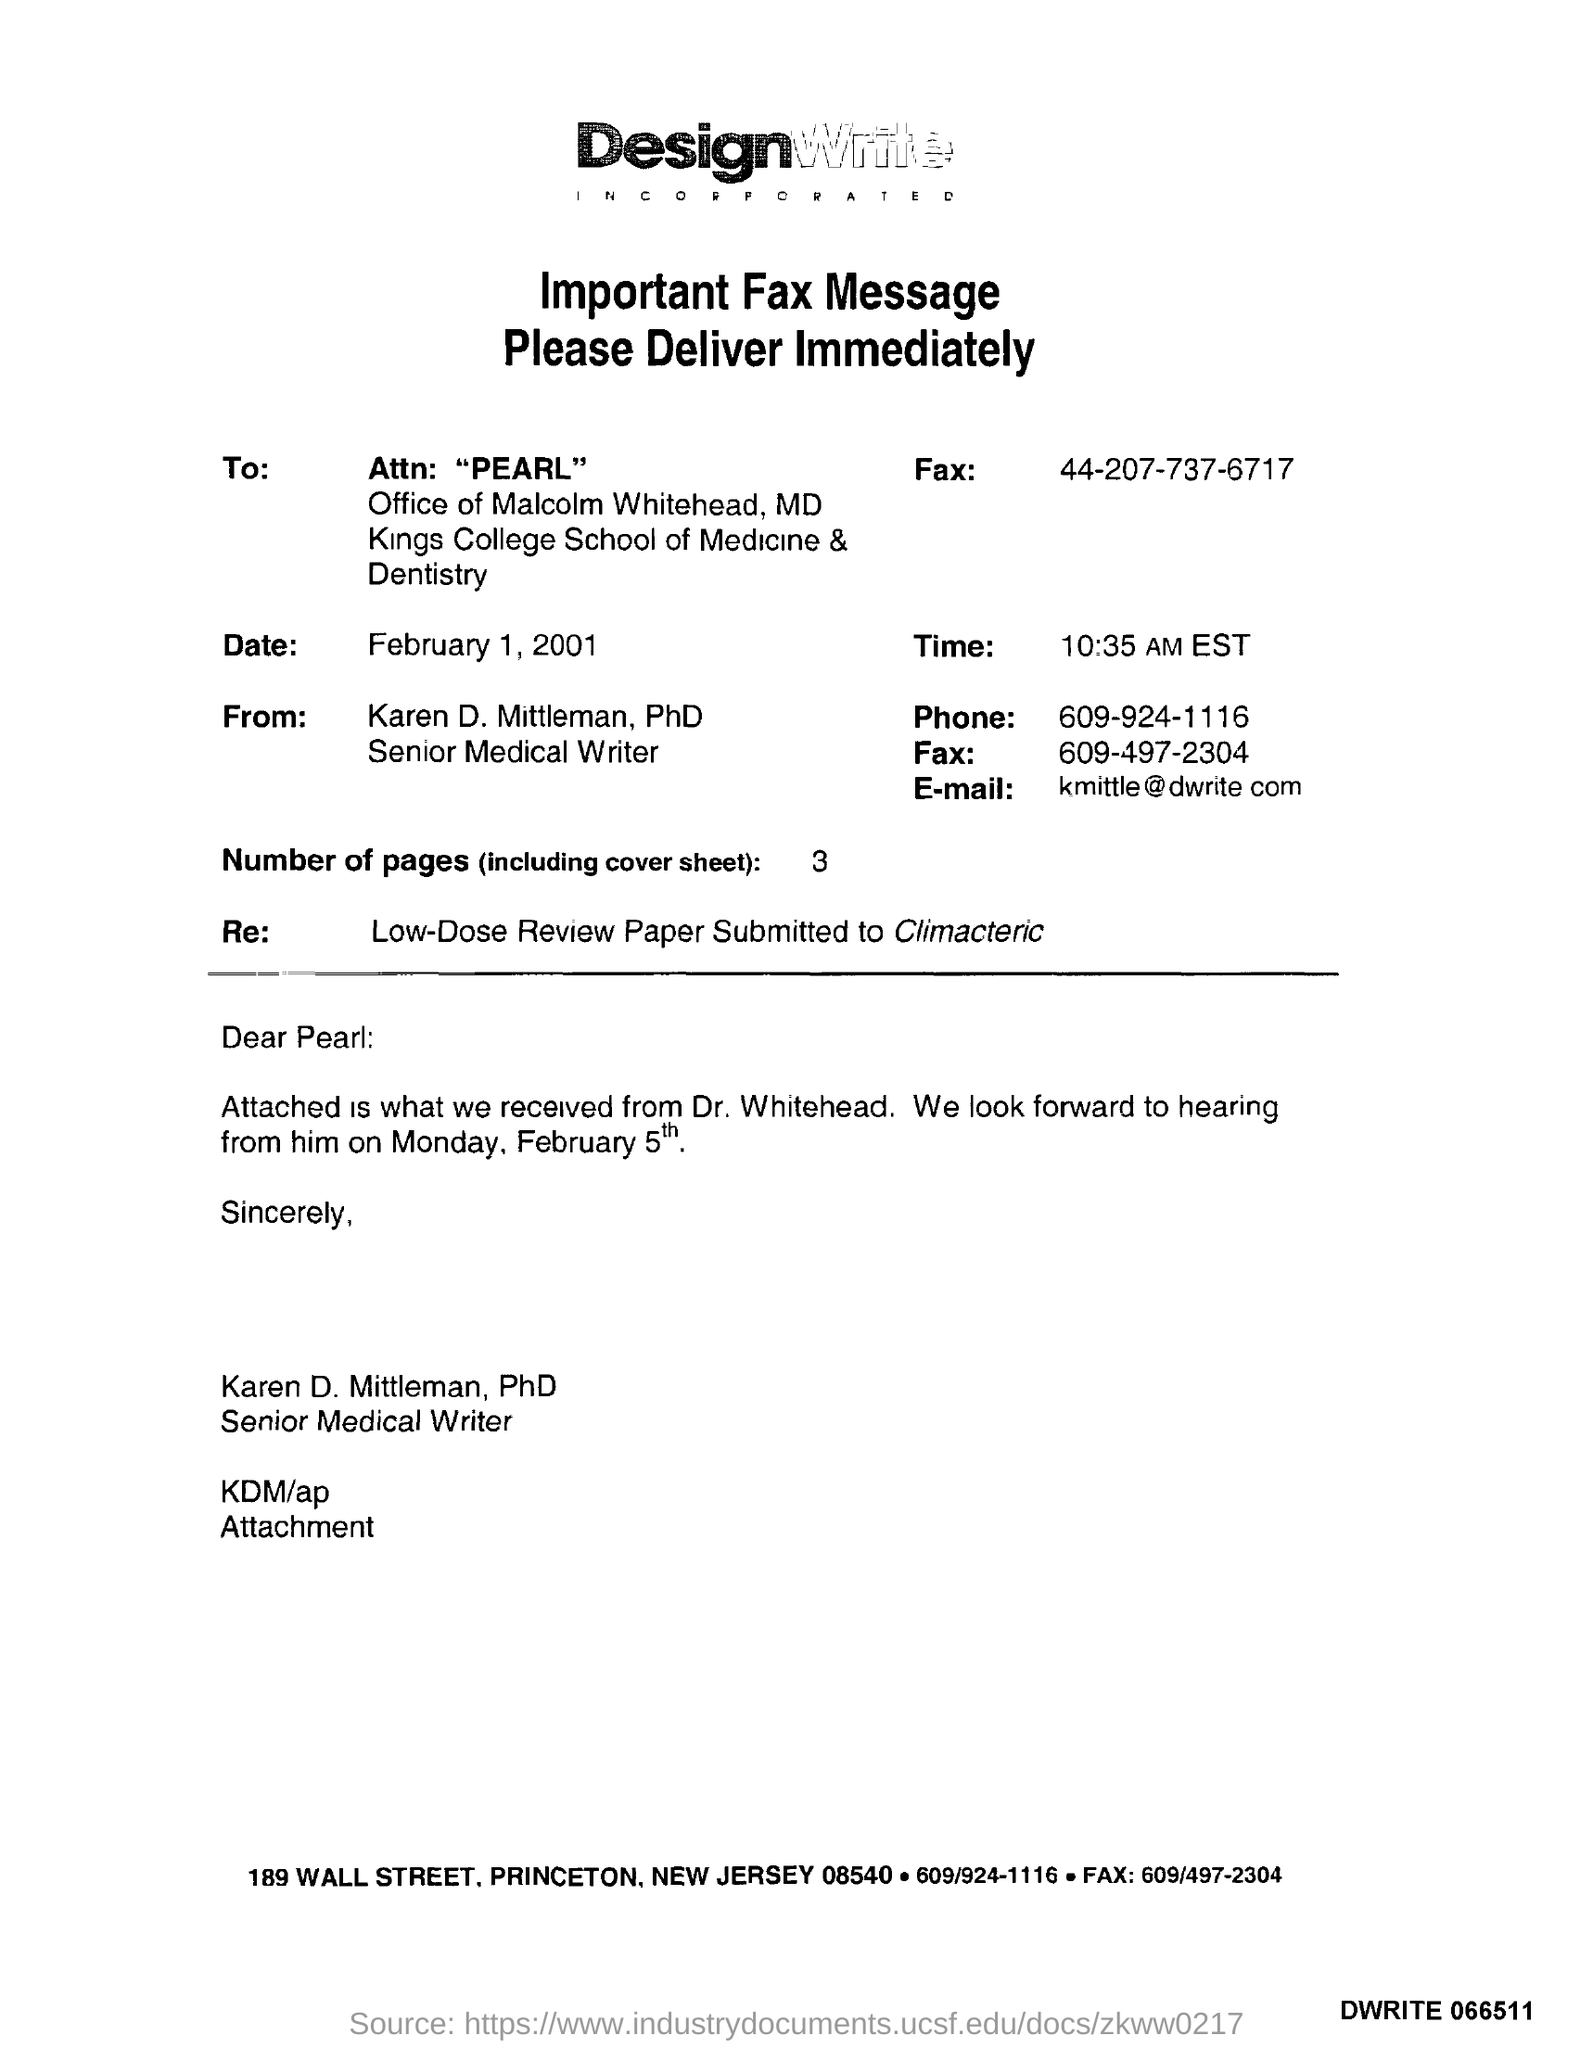Highlight a few significant elements in this photo. February 5th is Monday. 